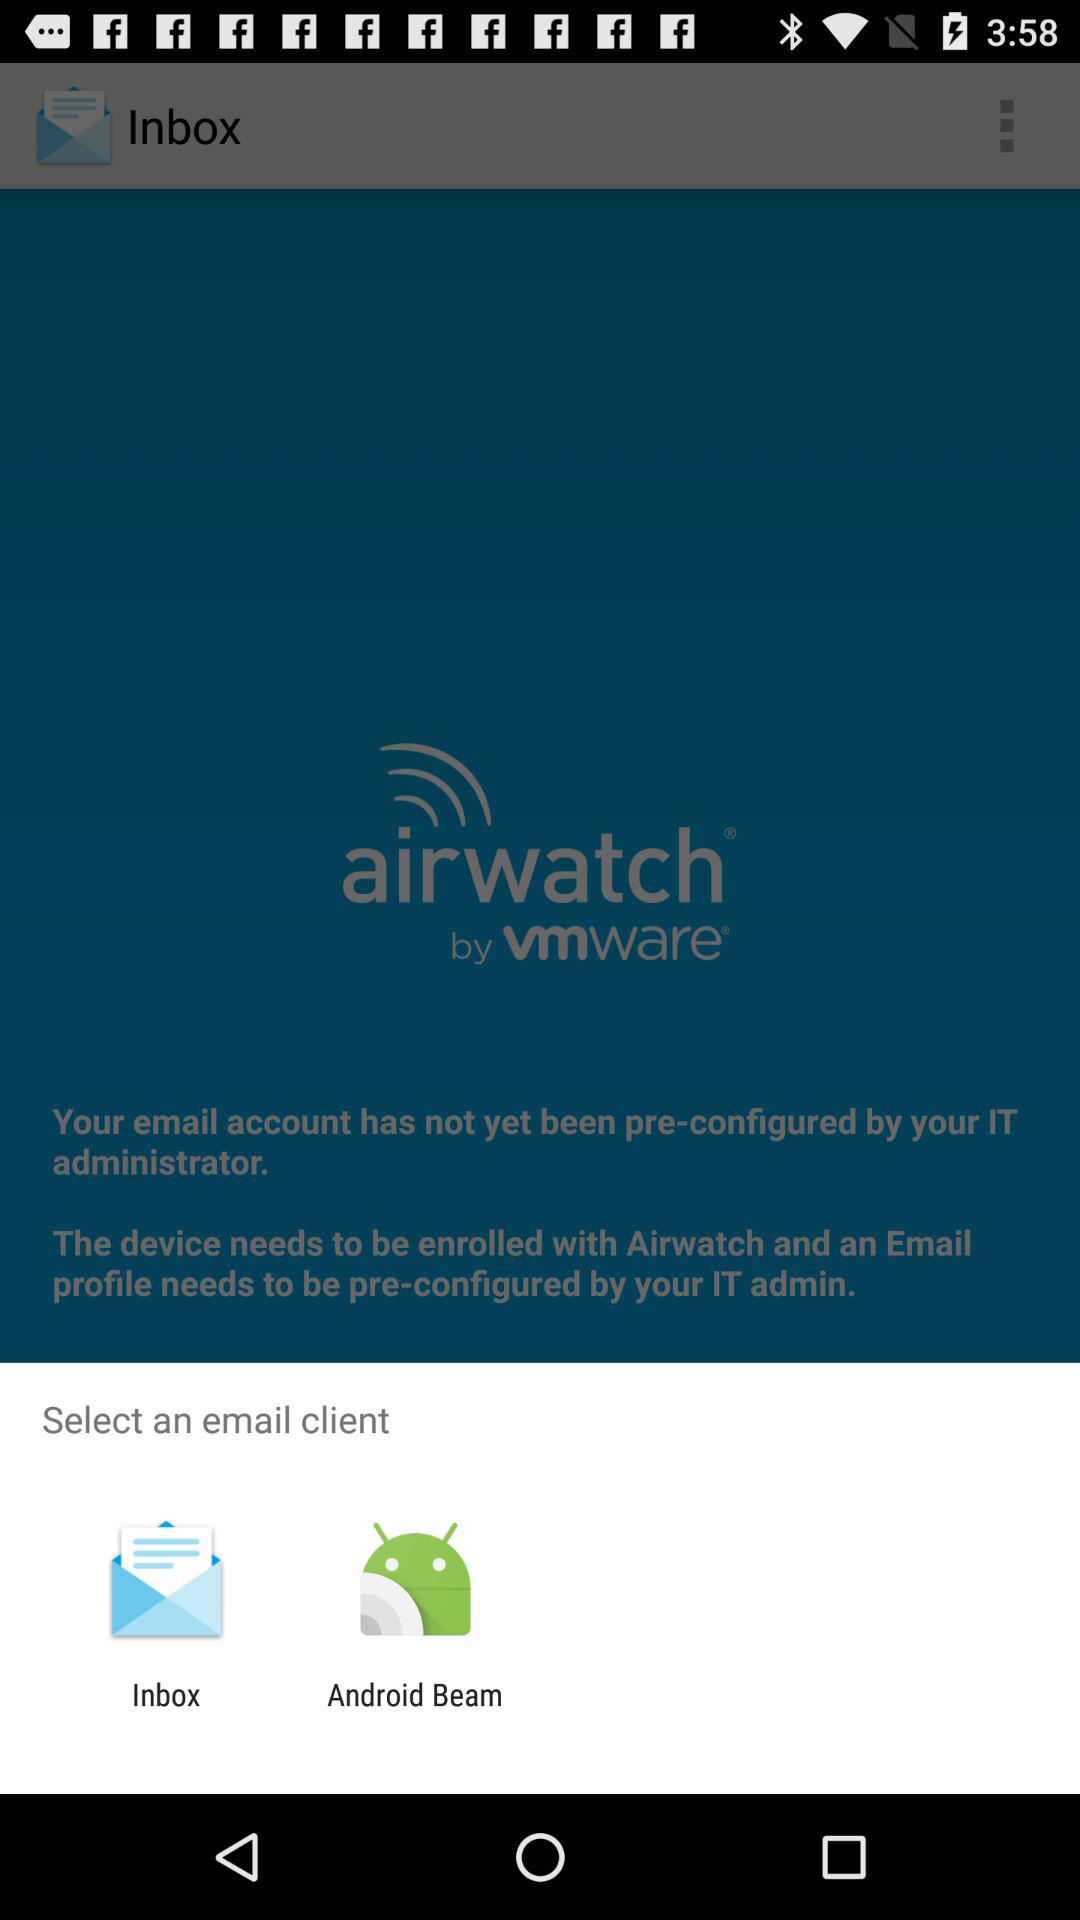What are the options to choose as an email client? The options are "Inbox" and "Android Beam". 